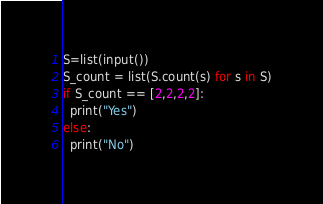Convert code to text. <code><loc_0><loc_0><loc_500><loc_500><_Python_>S=list(input())
S_count = list(S.count(s) for s in S)
if S_count == [2,2,2,2]:
  print("Yes")
else:
  print("No")
</code> 